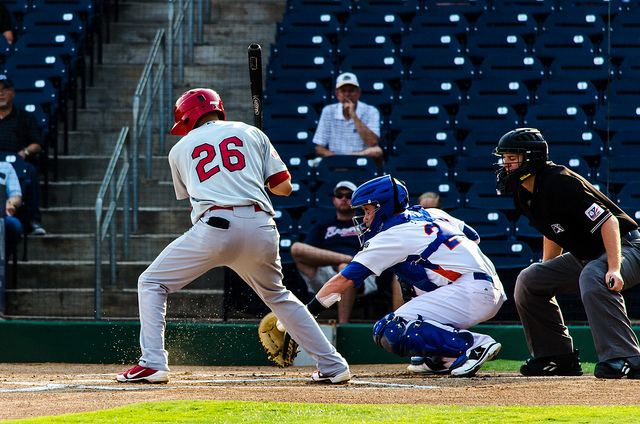Read and extract the text from this image. 26 